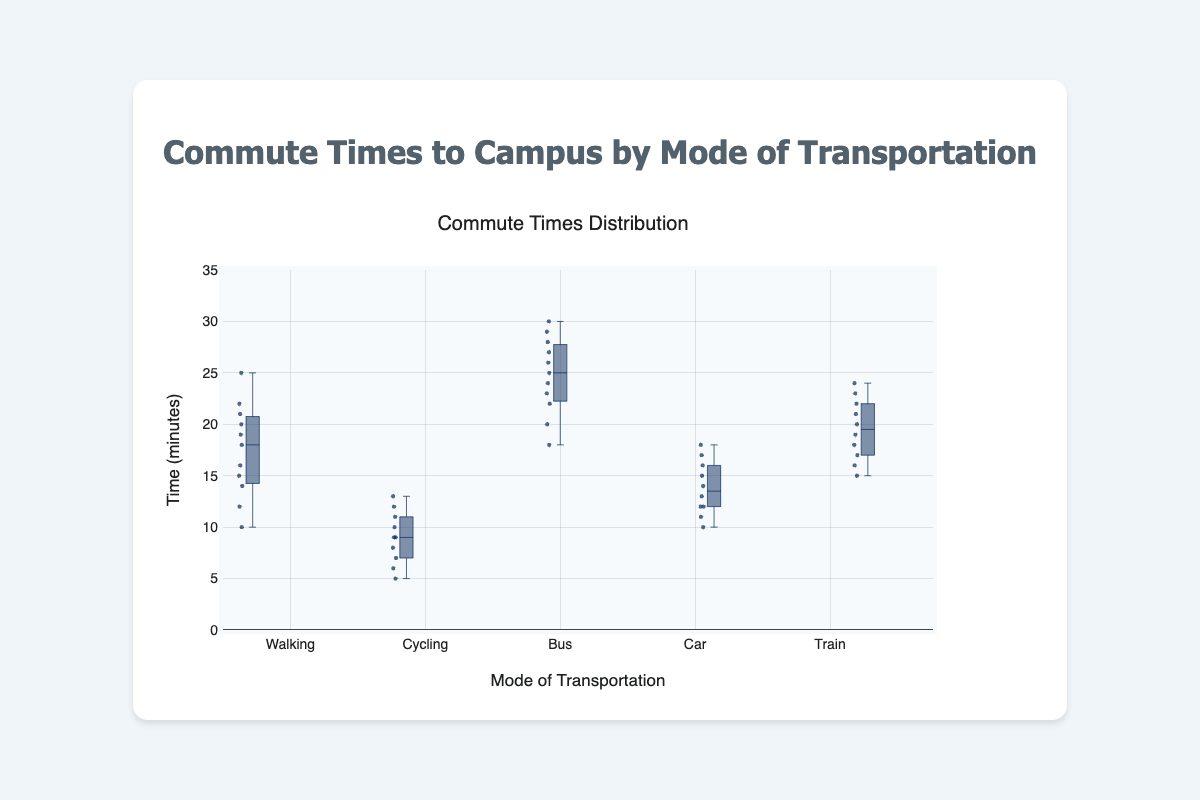What is the title of the plot? The title is typically at the top of the figure and summarizes the content being shown.
Answer: Commute Times to Campus by Mode of Transportation How many different modes of transportation are included in the plot? By counting the distinct box plots, you can determine the number of modes of transportation. In this case, four box plots are displayed.
Answer: 5 Which mode of transportation has the longest median commute time? The median is indicated by the line inside each box. Comparing the median lines of all boxes, Walking and Bus have the highest median.
Answer: Bus Which mode of transportation has the lowest median commute time? Similarly, checking the median lines shows that Cycling has the lowest median.
Answer: Cycling For the Walking mode, what is the range of the interquartile range (IQR)? The IQR is the distance between the first quartile (Q1) and the third quartile (Q3). For the Walking box plot, identify Q1 and Q3, then subtract Q1 from Q3.
Answer: 18 - 13 = 10 minutes What is the mode of transportation with the smallest overall range of commute times? The range is the difference between the maximum and minimum values. Compare the lengths of the whiskers for each box plot.
Answer: Cycling Which mode of transportation has the most outliers? Outliers are individual points beyond the whiskers of the box plots. By counting these points for each plot, Walking has no outliers, Cycling has one outlier, Bus has one outlier.
Answer: Bus How does the median commute time for the Car compare to the median for the Train? Compare the median lines (inside the boxes) of Car and Train. Both modes have almost identical medians, though it may vary slightly upon detailed observation.
Answer: Car median = Train median What can be said about the variability in commute times for Bus compared to Cycling? Variability is represented by the length of the box and whiskers. The Bus has a larger box and longer whiskers than Cycling, indicating higher variability.
Answer: Bus has higher variability 